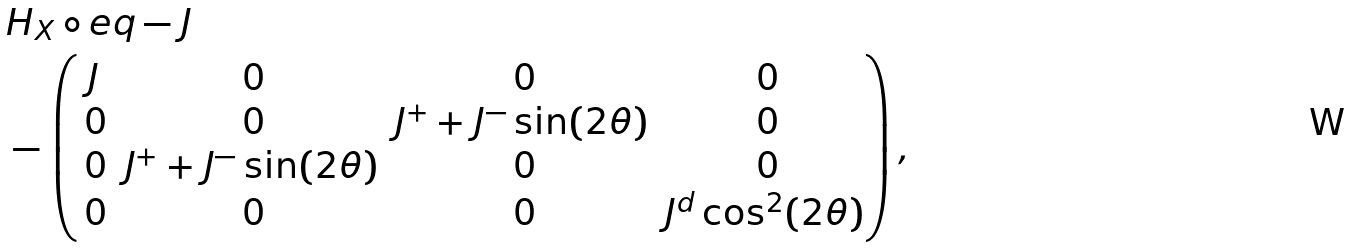Convert formula to latex. <formula><loc_0><loc_0><loc_500><loc_500>& H _ { X } \circ e q - J \\ & - \begin{pmatrix} J & \, 0 & \, 0 & \, 0 \\ \, 0 & \, 0 & J ^ { + } + J ^ { - } \sin ( 2 \theta ) & \, 0 \\ \, 0 & J ^ { + } + J ^ { - } \sin ( 2 \theta ) & \, 0 & \, 0 \\ \, 0 & \, 0 & \, 0 & J ^ { d } \cos ^ { 2 } ( 2 \theta ) \end{pmatrix} ,</formula> 